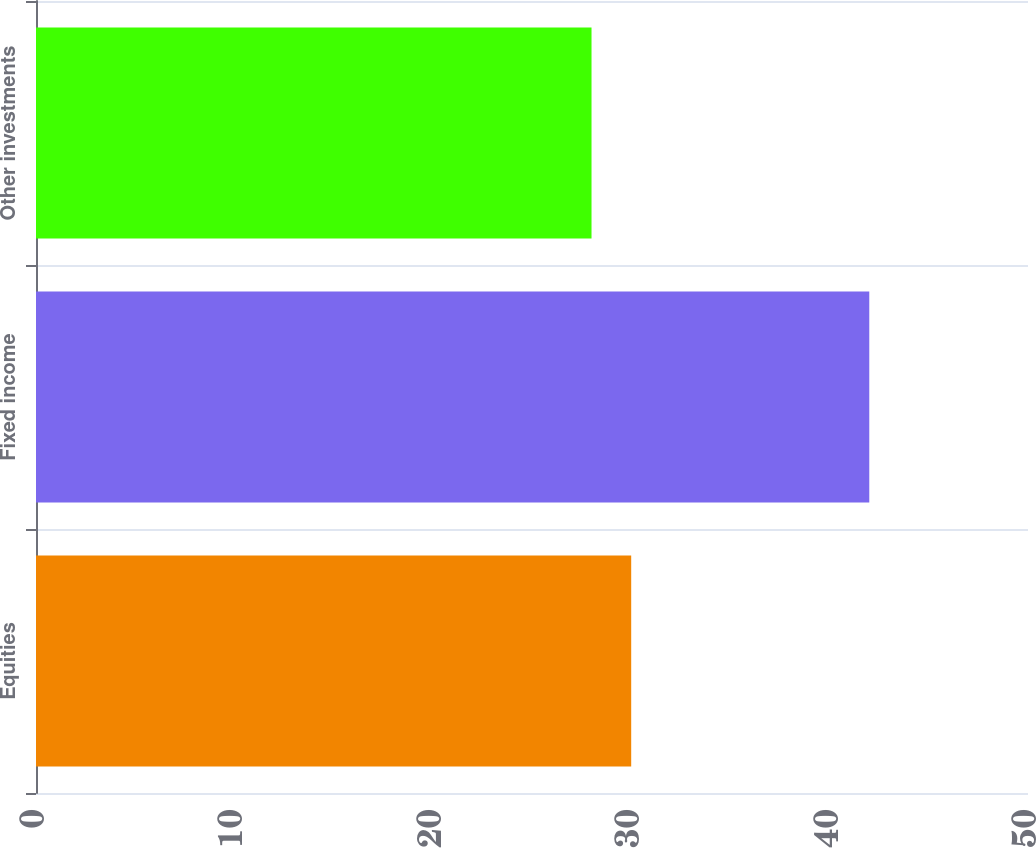Convert chart to OTSL. <chart><loc_0><loc_0><loc_500><loc_500><bar_chart><fcel>Equities<fcel>Fixed income<fcel>Other investments<nl><fcel>30<fcel>42<fcel>28<nl></chart> 